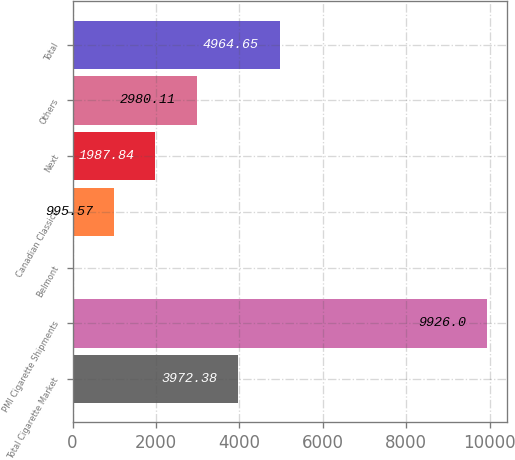Convert chart to OTSL. <chart><loc_0><loc_0><loc_500><loc_500><bar_chart><fcel>Total Cigarette Market<fcel>PMI Cigarette Shipments<fcel>Belmont<fcel>Canadian Classics<fcel>Next<fcel>Others<fcel>Total<nl><fcel>3972.38<fcel>9926<fcel>3.3<fcel>995.57<fcel>1987.84<fcel>2980.11<fcel>4964.65<nl></chart> 